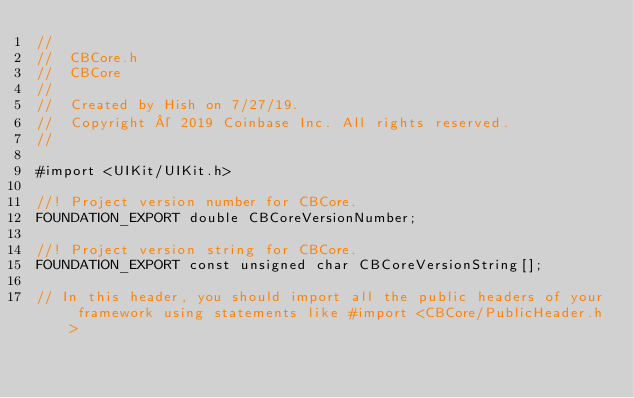<code> <loc_0><loc_0><loc_500><loc_500><_C_>//
//  CBCore.h
//  CBCore
//
//  Created by Hish on 7/27/19.
//  Copyright © 2019 Coinbase Inc. All rights reserved.
//

#import <UIKit/UIKit.h>

//! Project version number for CBCore.
FOUNDATION_EXPORT double CBCoreVersionNumber;

//! Project version string for CBCore.
FOUNDATION_EXPORT const unsigned char CBCoreVersionString[];

// In this header, you should import all the public headers of your framework using statements like #import <CBCore/PublicHeader.h>


</code> 